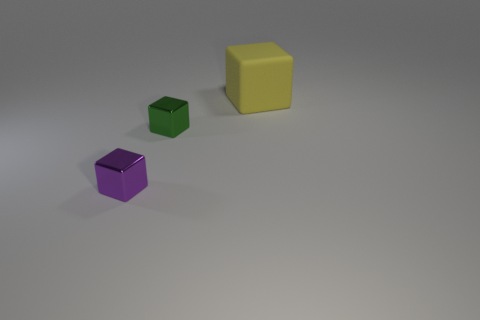Add 3 big blue shiny spheres. How many objects exist? 6 Subtract 1 blocks. How many blocks are left? 2 Subtract all green blocks. How many blocks are left? 2 Subtract all metallic cubes. How many cubes are left? 1 Subtract 0 gray spheres. How many objects are left? 3 Subtract all red blocks. Subtract all gray balls. How many blocks are left? 3 Subtract all blue cylinders. How many yellow blocks are left? 1 Subtract all rubber cylinders. Subtract all tiny green objects. How many objects are left? 2 Add 2 big yellow cubes. How many big yellow cubes are left? 3 Add 3 large cyan blocks. How many large cyan blocks exist? 3 